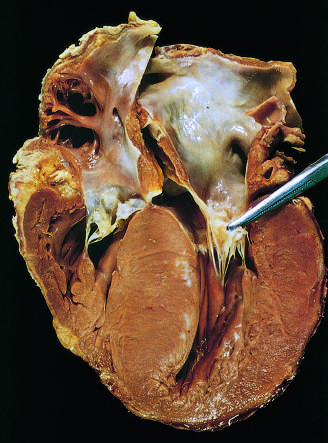does the septal muscle bulge into the left ventricular outflow tract, giving rise to a banana-shaped ventricular lumen?
Answer the question using a single word or phrase. Yes 